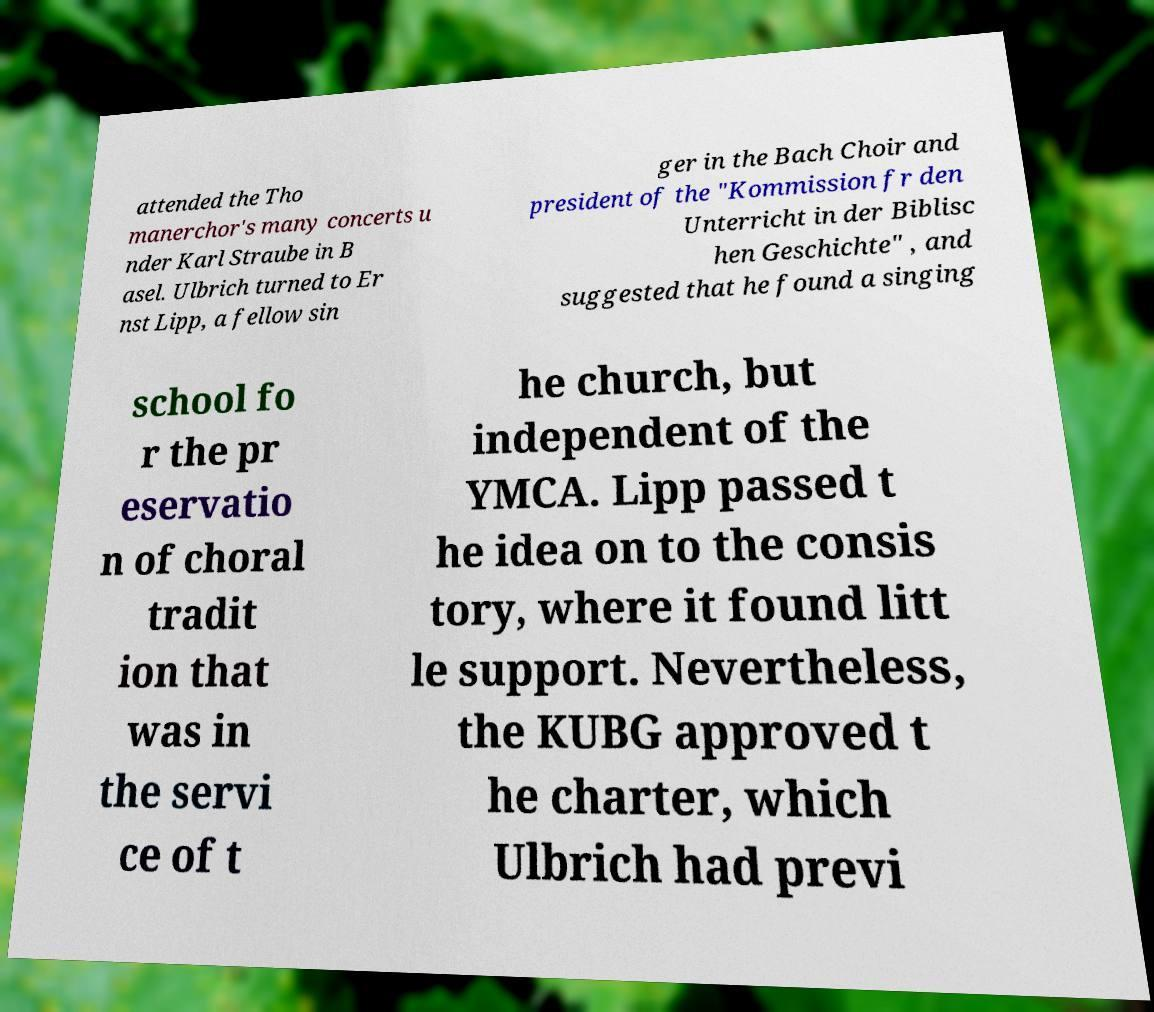Please read and relay the text visible in this image. What does it say? attended the Tho manerchor's many concerts u nder Karl Straube in B asel. Ulbrich turned to Er nst Lipp, a fellow sin ger in the Bach Choir and president of the "Kommission fr den Unterricht in der Biblisc hen Geschichte" , and suggested that he found a singing school fo r the pr eservatio n of choral tradit ion that was in the servi ce of t he church, but independent of the YMCA. Lipp passed t he idea on to the consis tory, where it found litt le support. Nevertheless, the KUBG approved t he charter, which Ulbrich had previ 